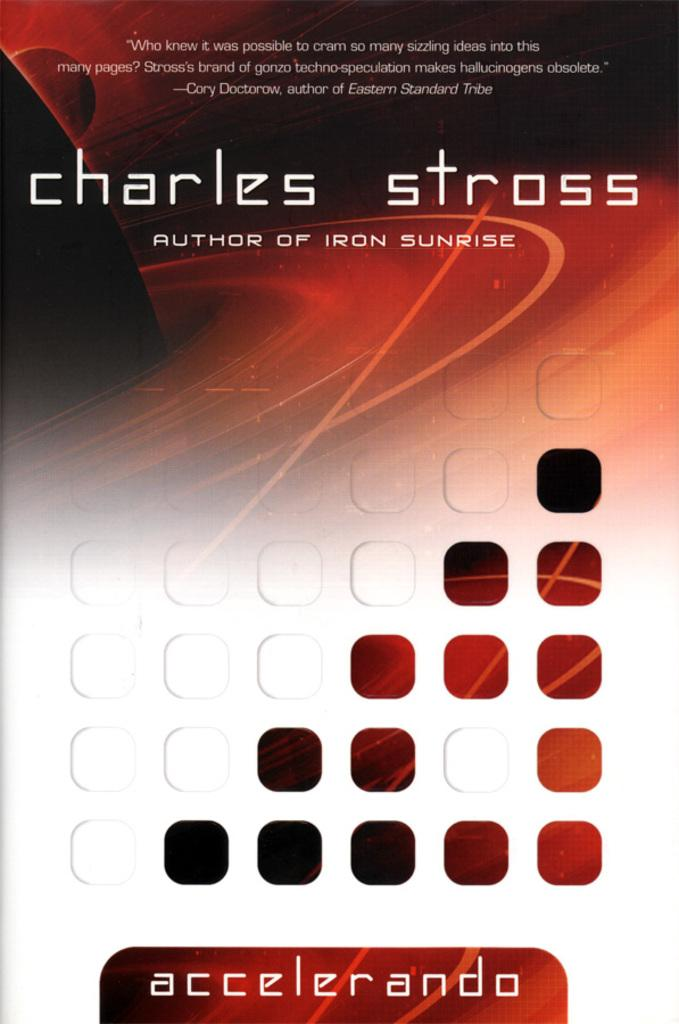<image>
Give a short and clear explanation of the subsequent image. A book cover lists its author as someone named Charles Stross. 